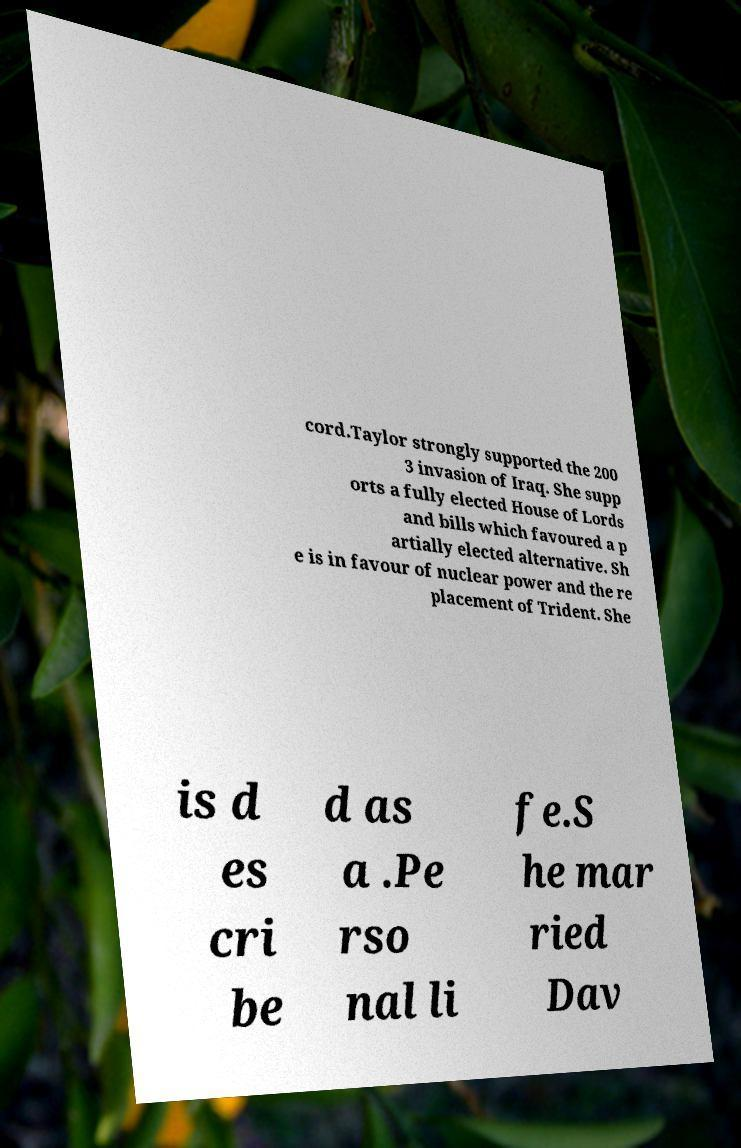Please identify and transcribe the text found in this image. cord.Taylor strongly supported the 200 3 invasion of Iraq. She supp orts a fully elected House of Lords and bills which favoured a p artially elected alternative. Sh e is in favour of nuclear power and the re placement of Trident. She is d es cri be d as a .Pe rso nal li fe.S he mar ried Dav 